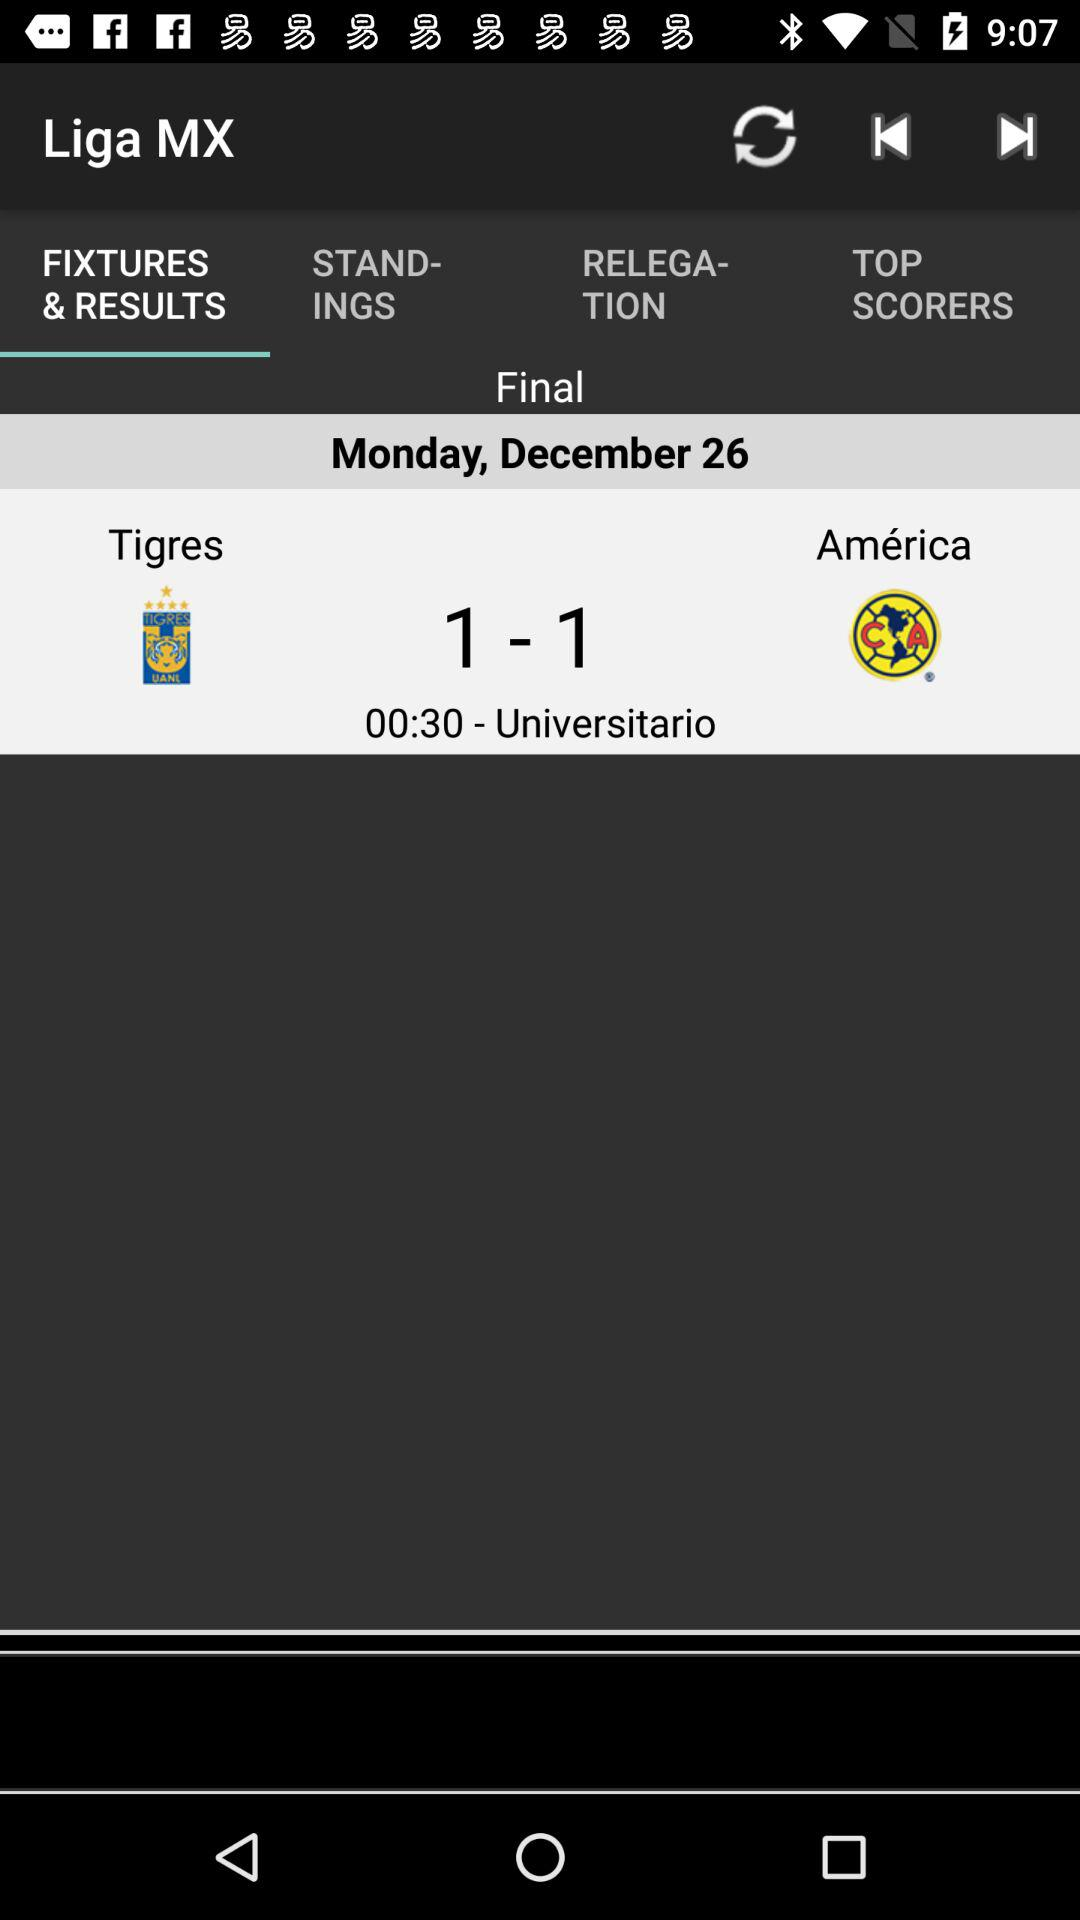How many goals were scored in the game between Tigres and América?
Answer the question using a single word or phrase. 2 